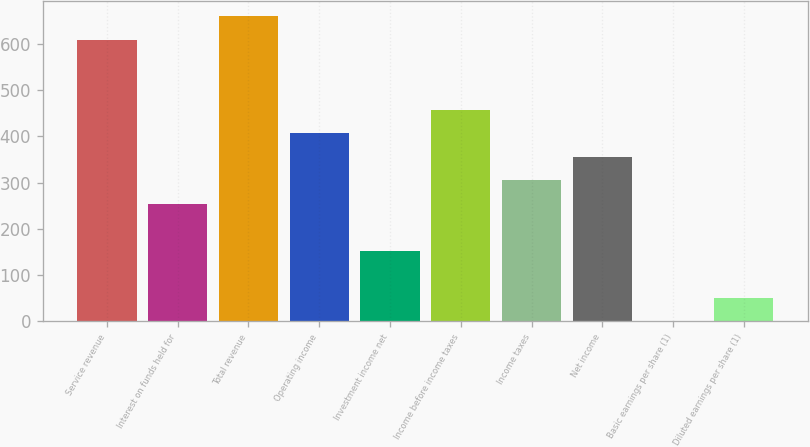Convert chart. <chart><loc_0><loc_0><loc_500><loc_500><bar_chart><fcel>Service revenue<fcel>Interest on funds held for<fcel>Total revenue<fcel>Operating income<fcel>Investment income net<fcel>Income before income taxes<fcel>Income taxes<fcel>Net income<fcel>Basic earnings per share (1)<fcel>Diluted earnings per share (1)<nl><fcel>609.31<fcel>254.06<fcel>660.06<fcel>406.31<fcel>152.56<fcel>457.06<fcel>304.81<fcel>355.56<fcel>0.31<fcel>51.06<nl></chart> 